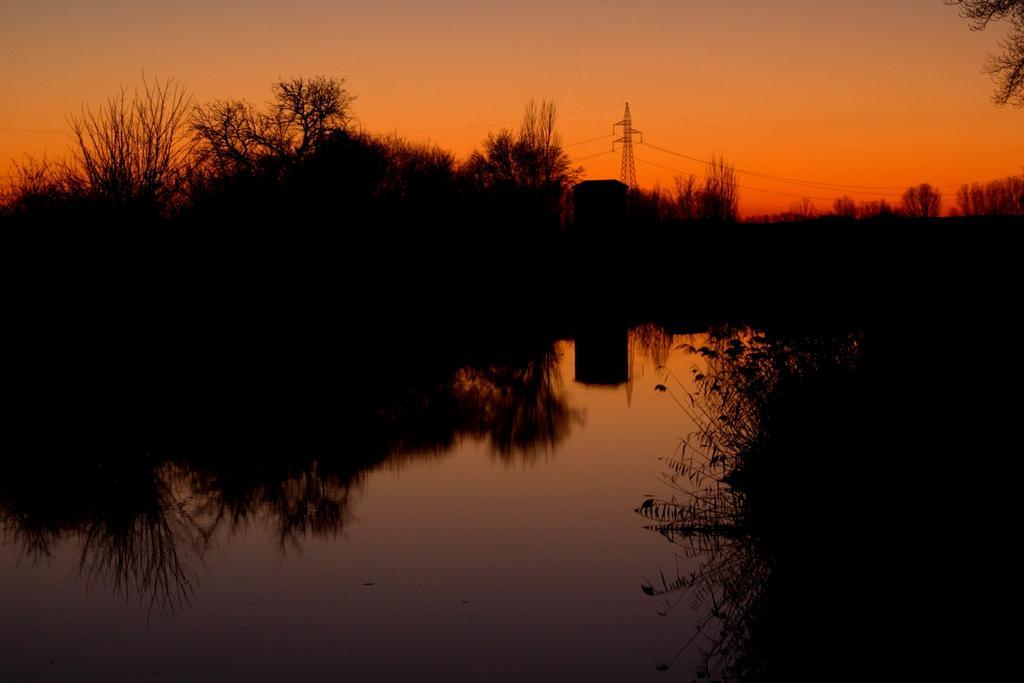Can you describe this image briefly? In the foreground of this image, there is water and trees. In the background, there is a tower, cables and the sky. 